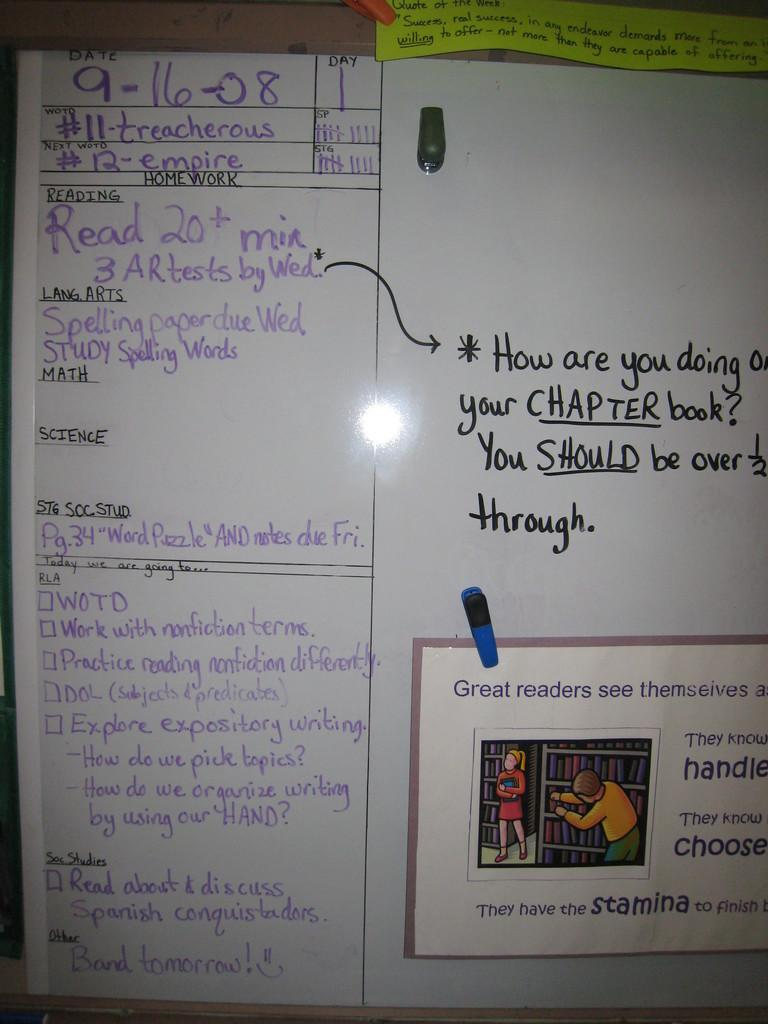<image>
Summarize the visual content of the image. A whiteboard dated sept 16 2008 for reading homework 